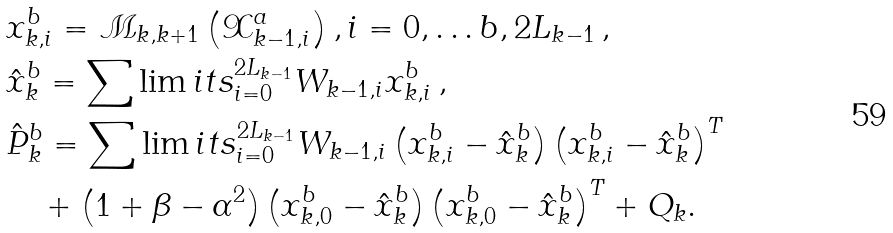<formula> <loc_0><loc_0><loc_500><loc_500>& x _ { k , i } ^ { b } = \mathcal { M } _ { k , k + 1 } \left ( \mathcal { X } _ { k - 1 , i } ^ { a } \right ) , i = 0 , \dots b , 2 L _ { k - 1 } \, , \\ & \hat { x } _ { k } ^ { b } = \sum \lim i t s _ { i = 0 } ^ { 2 L _ { k - 1 } } W _ { k - 1 , i } x _ { k , i } ^ { b } \, , \\ & \hat { P } _ { k } ^ { b } = \sum \lim i t s _ { i = 0 } ^ { 2 L _ { k - 1 } } W _ { k - 1 , i } \left ( x _ { k , i } ^ { b } - \hat { x } _ { k } ^ { b } \right ) \left ( x _ { k , i } ^ { b } - \hat { x } _ { k } ^ { b } \right ) ^ { T } \\ & \quad + \left ( 1 + \beta - \alpha ^ { 2 } \right ) \left ( x _ { k , 0 } ^ { b } - \hat { x } _ { k } ^ { b } \right ) \left ( x _ { k , 0 } ^ { b } - \hat { x } _ { k } ^ { b } \right ) ^ { T } + Q _ { k } .</formula> 